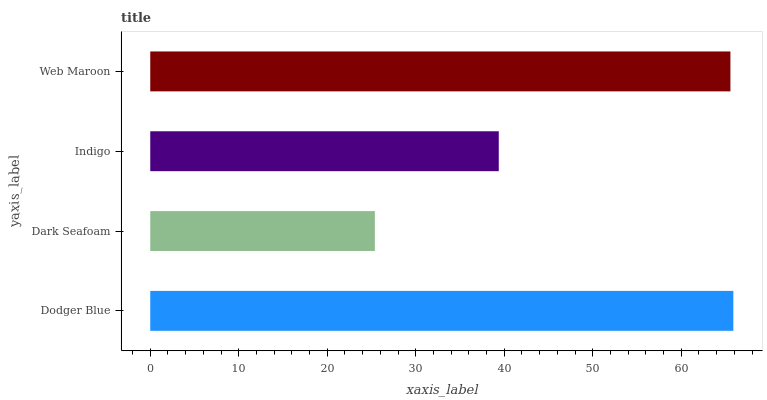Is Dark Seafoam the minimum?
Answer yes or no. Yes. Is Dodger Blue the maximum?
Answer yes or no. Yes. Is Indigo the minimum?
Answer yes or no. No. Is Indigo the maximum?
Answer yes or no. No. Is Indigo greater than Dark Seafoam?
Answer yes or no. Yes. Is Dark Seafoam less than Indigo?
Answer yes or no. Yes. Is Dark Seafoam greater than Indigo?
Answer yes or no. No. Is Indigo less than Dark Seafoam?
Answer yes or no. No. Is Web Maroon the high median?
Answer yes or no. Yes. Is Indigo the low median?
Answer yes or no. Yes. Is Indigo the high median?
Answer yes or no. No. Is Web Maroon the low median?
Answer yes or no. No. 